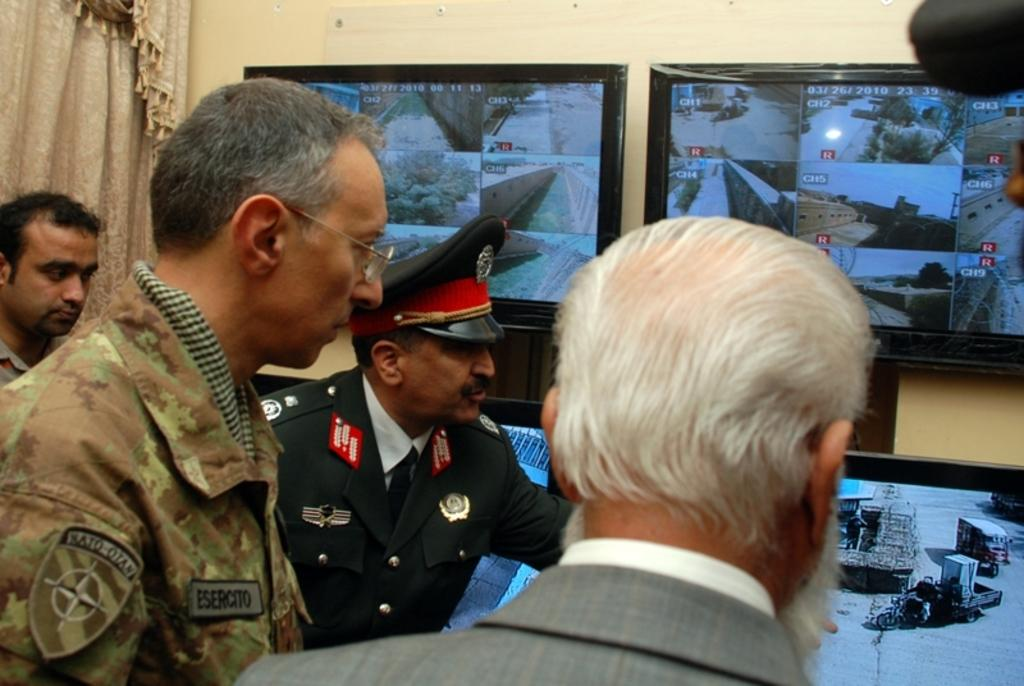Who or what can be seen in the image? There are people in the image. What electronic devices are present in the image? There are televisions in the image. What type of architectural feature is visible in the image? There is a wall in the image. What type of window treatment is present in the image? There is a curtain in the image. Reasoning: Let' Let's think step by step in order to produce the conversation. We start by identifying the main subjects in the image, which are the people and televisions. Then, we expand the conversation to include other elements of the image, such as the wall and curtain. Each question is designed to elicit a specific details about the image that are known from the provided facts. Absurd Question/Answer: What type of wax sculpture can be seen on the street in the image? There is no wax sculpture or street present in the image; it only features people, televisions, a wall, and a curtain. What type of wax sculpture can be seen on the street in the image? There is no wax sculpture or street present in the image; it only features people, televisions, a wall, and a curtain. 